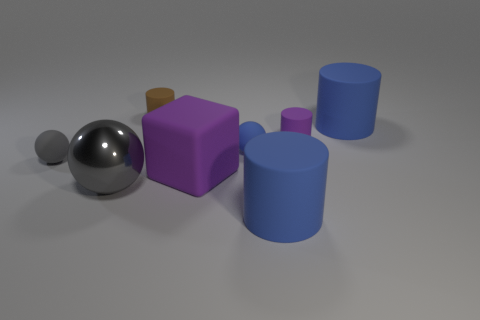How many blue cylinders must be subtracted to get 1 blue cylinders? 1 Subtract 2 cylinders. How many cylinders are left? 2 Subtract all brown blocks. How many blue cylinders are left? 2 Subtract all brown cylinders. How many cylinders are left? 3 Subtract all big balls. How many balls are left? 2 Subtract all red cylinders. Subtract all gray blocks. How many cylinders are left? 4 Add 1 blue rubber cylinders. How many objects exist? 9 Subtract all balls. How many objects are left? 5 Add 2 small rubber cylinders. How many small rubber cylinders exist? 4 Subtract 1 purple cylinders. How many objects are left? 7 